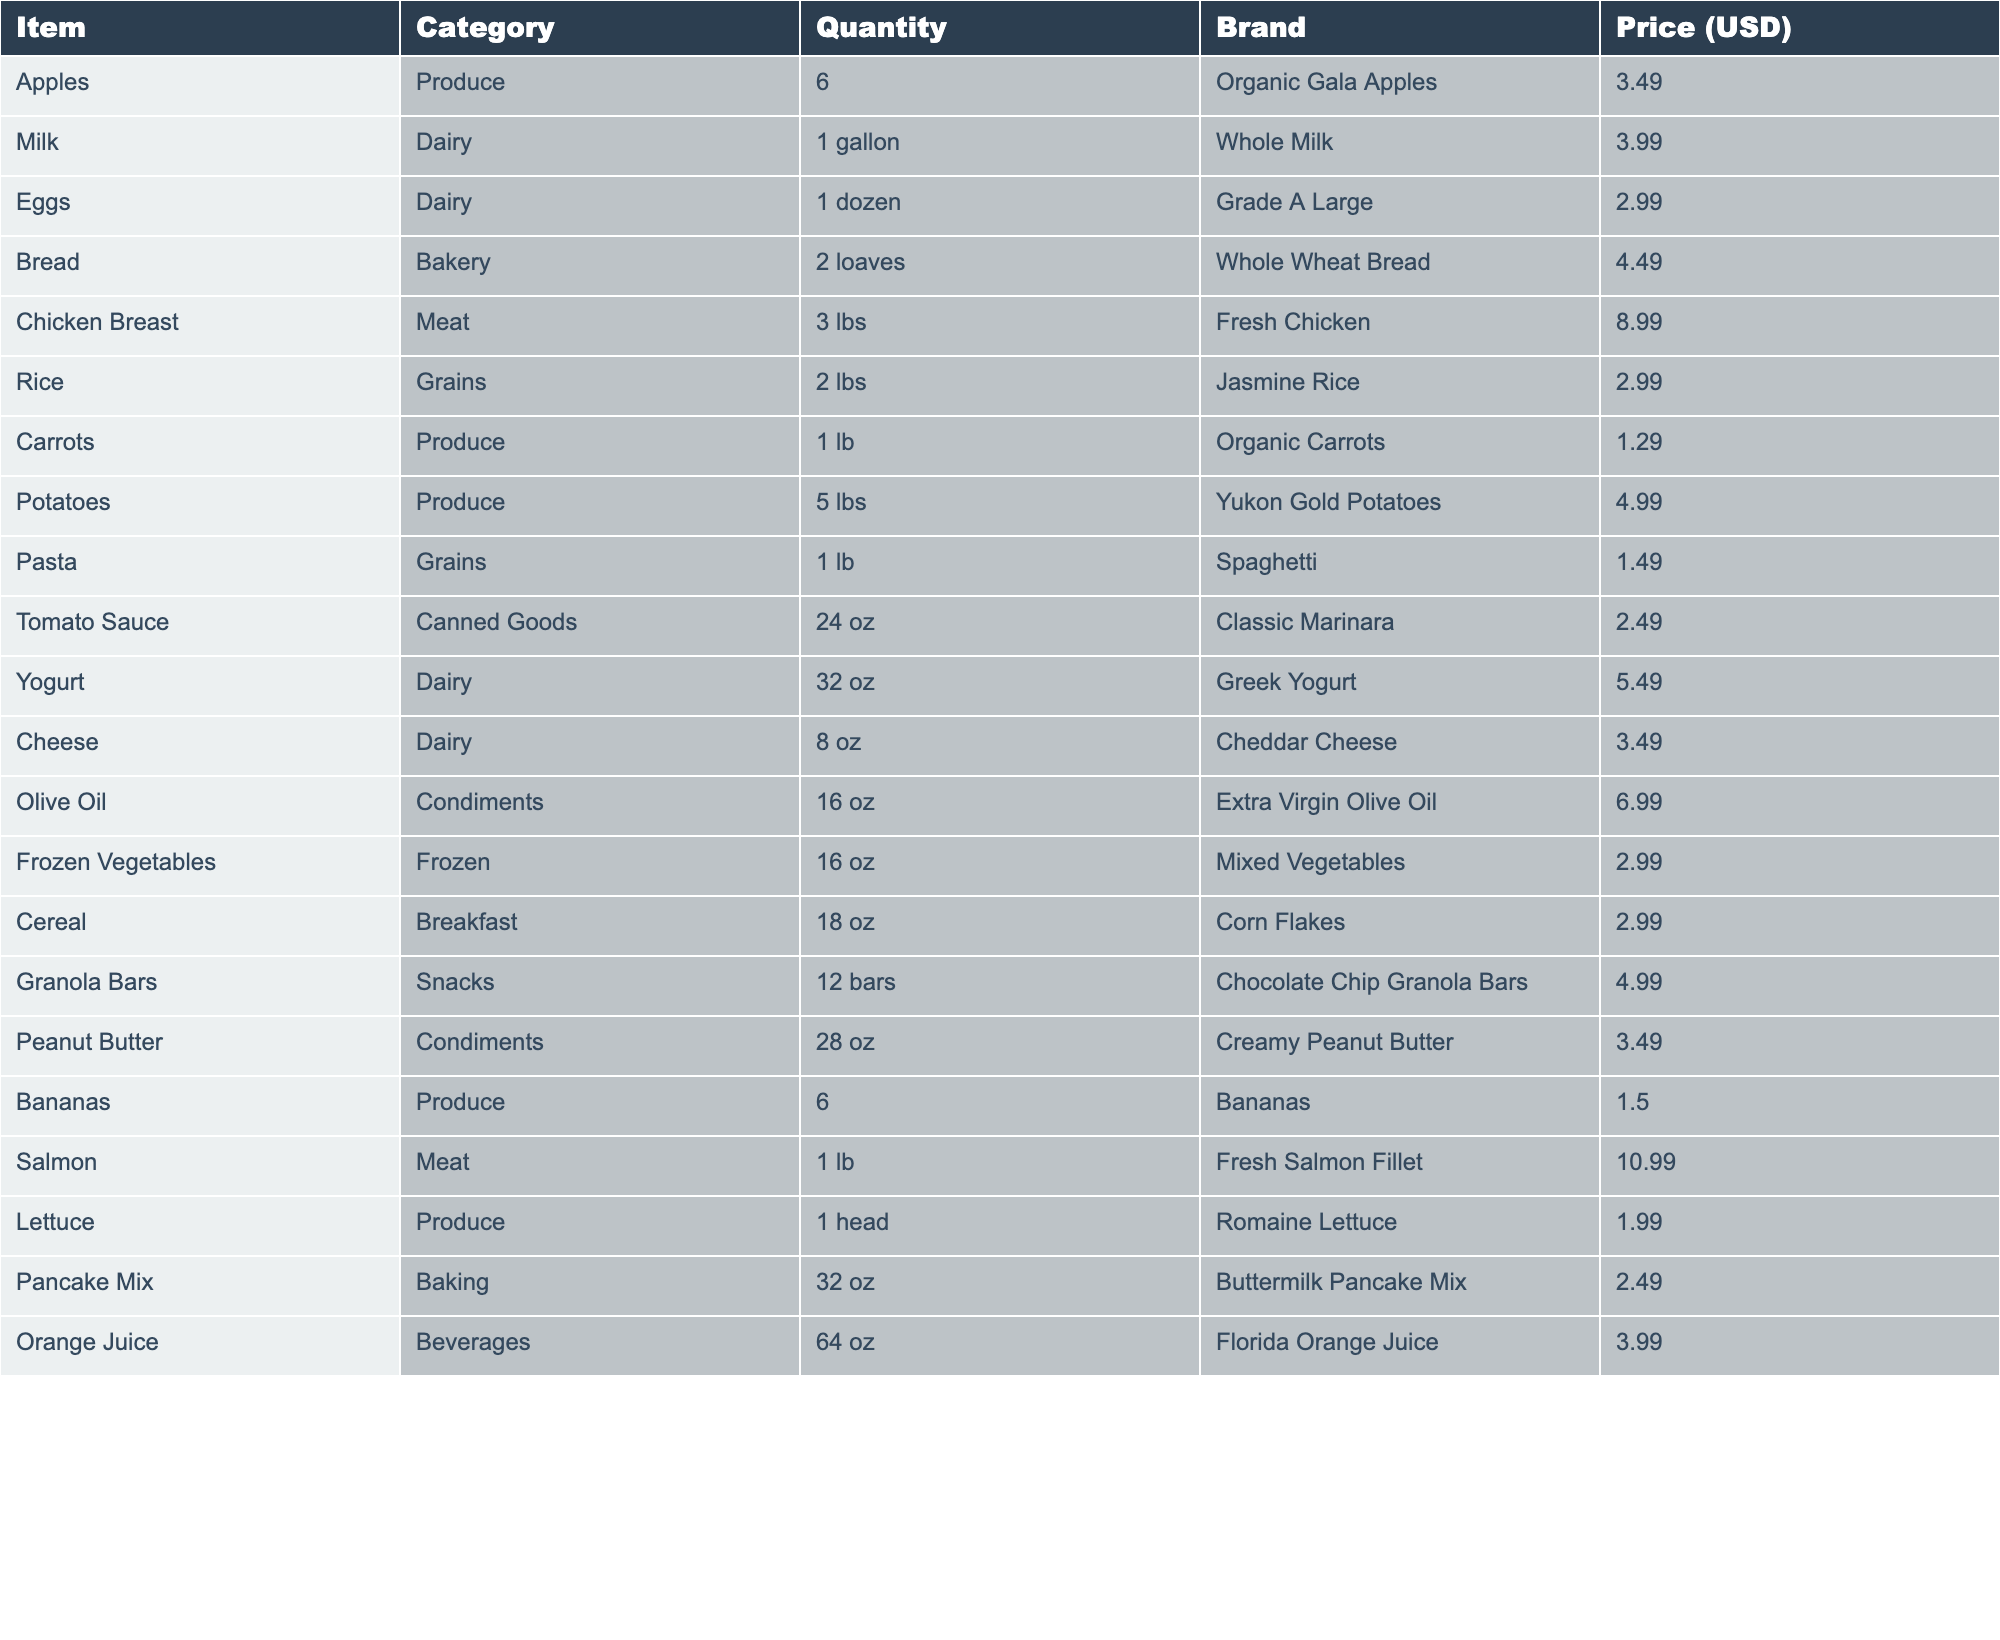What is the total cost of buying 6 apples? The price for 6 organic Gala apples is listed as $3.49. So, the total cost is simply $3.49 since this is the quantity indicated in the table.
Answer: 3.49 How many loaves of bread are in the shopping list? The table shows that there are 2 loaves of whole wheat bread listed under the bakery category.
Answer: 2 What is the price of a gallon of milk and what type is it? The table states that a gallon of whole milk is priced at $3.99. The type is whole milk.
Answer: 3.99, Whole Milk What is the combined quantity of produce items on the list? The produce items are apples (6), carrots (1 lb), potatoes (5 lbs), bananas (6), and lettuce (1 head). Adding these quantities gives us 6 + 1 + 5 + 6 + 1 = 19.
Answer: 19 Is there any canned goods in the grocery list? The table lists one item under canned goods, which is the classic marinara tomato sauce. Therefore, the answer is yes.
Answer: Yes What is the average price of the dairy products in the list? The dairy products are milk ($3.99), eggs ($2.99), yogurt ($5.49), and cheese ($3.49). The total price is 3.99 + 2.99 + 5.49 + 3.49 = 16.96, and there are 4 items. So, the average is 16.96 / 4 = 4.24.
Answer: 4.24 Which item is the most expensive in the list, and what is its price? By scanning through the prices listed in the table, the fresh salmon fillet is the most expensive item at $10.99.
Answer: Fresh Salmon Fillet, 10.99 How many more pounds of chicken breast can you buy if you have $20? The price of chicken breast is $8.99 per 3 lbs. With $20, you can buy 20 / 8.99 = 2.22 (approx. 2 purchases) which equals 6.66 lbs. Subtracting the initial 3 lbs, you can buy an additional 3.66 lbs.
Answer: 3.66 lbs How much cheaper is a pound of pasta compared to a pound of rice? The price of pasta is $1.49 and the price of rice is $2.99. Subtracting the two prices gives us 2.99 - 1.49 = 1.50. Therefore, pasta is $1.50 cheaper than rice.
Answer: 1.50 Are there any snacks included in the grocery list? The table includes one snack item, which is chocolate chip granola bars. Hence, the answer is yes.
Answer: Yes 